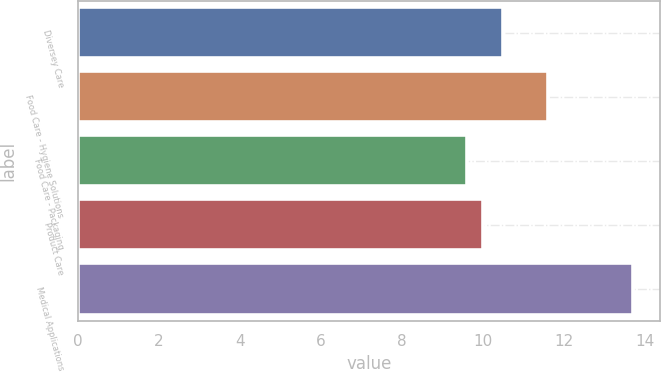Convert chart to OTSL. <chart><loc_0><loc_0><loc_500><loc_500><bar_chart><fcel>Diversey Care<fcel>Food Care - Hygiene Solutions<fcel>Food Care - Packaging<fcel>Product Care<fcel>Medical Applications<nl><fcel>10.5<fcel>11.6<fcel>9.6<fcel>10.01<fcel>13.7<nl></chart> 